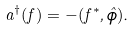<formula> <loc_0><loc_0><loc_500><loc_500>a ^ { \dagger } ( f ) = - ( f ^ { * } , \hat { \phi } ) .</formula> 